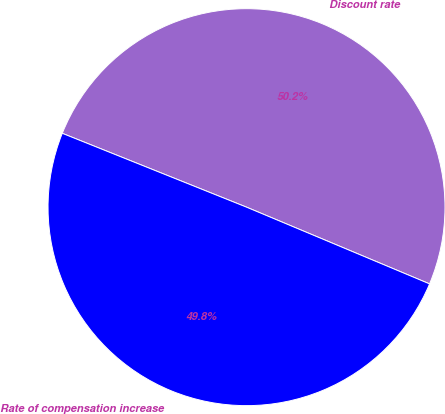<chart> <loc_0><loc_0><loc_500><loc_500><pie_chart><fcel>Discount rate<fcel>Rate of compensation increase<nl><fcel>50.25%<fcel>49.75%<nl></chart> 